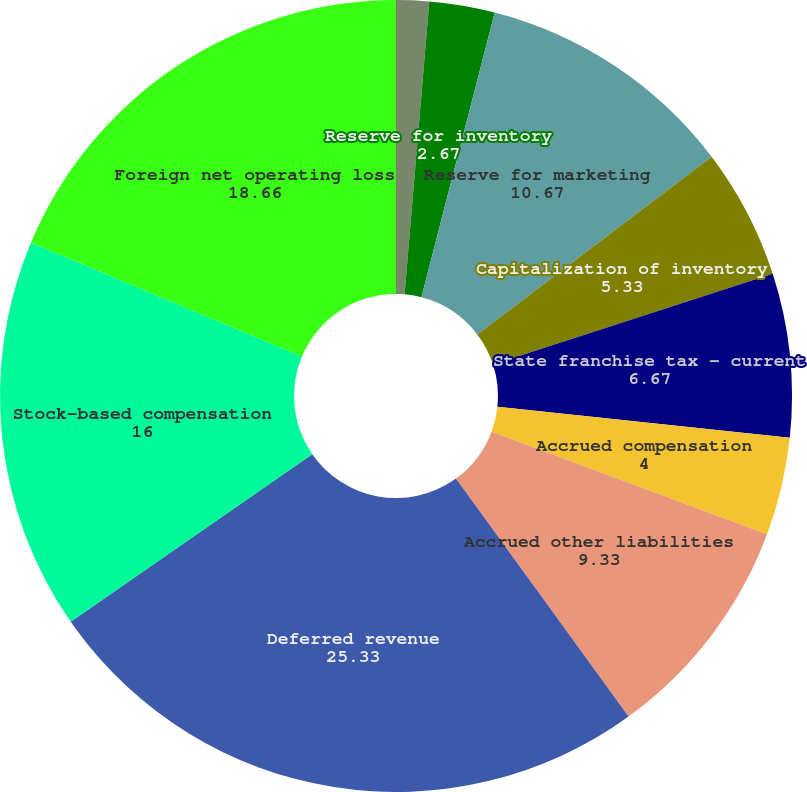<chart> <loc_0><loc_0><loc_500><loc_500><pie_chart><fcel>Reserve for sales returns<fcel>Reserve for inventory<fcel>Reserve for marketing<fcel>Capitalization of inventory<fcel>State franchise tax - current<fcel>Accrued compensation<fcel>Accrued other liabilities<fcel>Deferred revenue<fcel>Stock-based compensation<fcel>Foreign net operating loss<nl><fcel>1.34%<fcel>2.67%<fcel>10.67%<fcel>5.33%<fcel>6.67%<fcel>4.0%<fcel>9.33%<fcel>25.33%<fcel>16.0%<fcel>18.66%<nl></chart> 